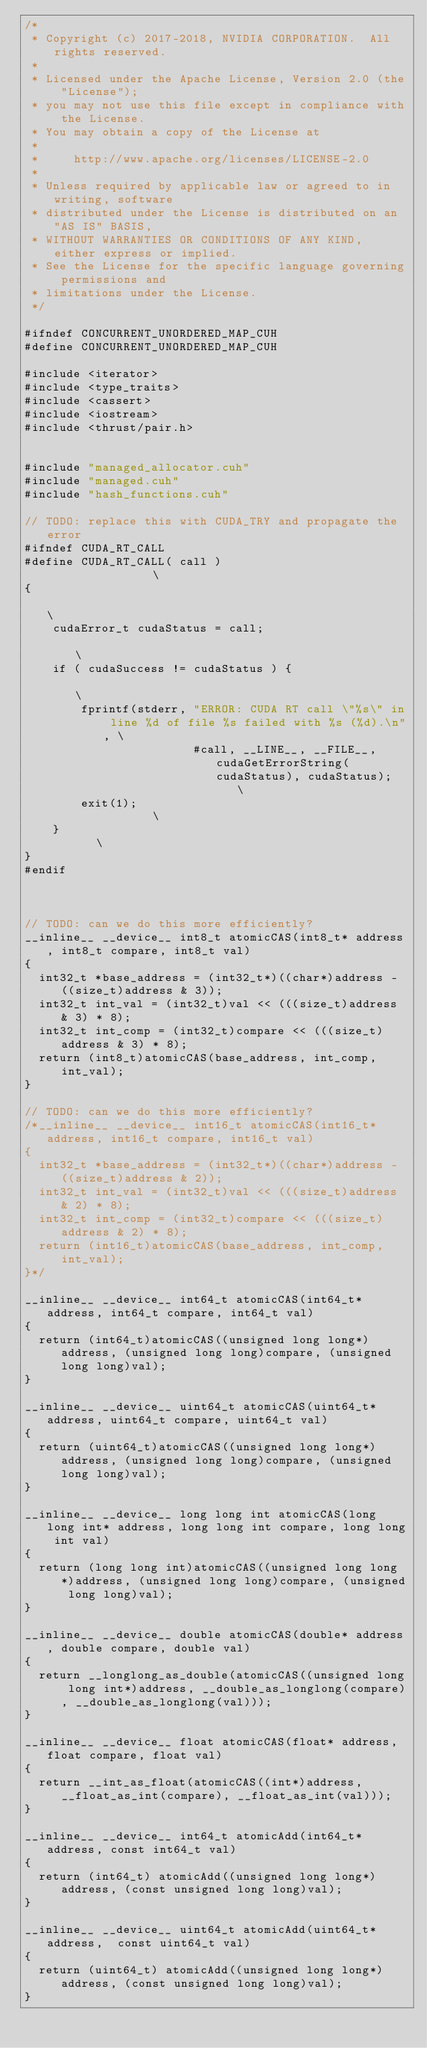Convert code to text. <code><loc_0><loc_0><loc_500><loc_500><_Cuda_>/*
 * Copyright (c) 2017-2018, NVIDIA CORPORATION.  All rights reserved.
 *
 * Licensed under the Apache License, Version 2.0 (the "License");
 * you may not use this file except in compliance with the License.
 * You may obtain a copy of the License at
 *
 *     http://www.apache.org/licenses/LICENSE-2.0
 *
 * Unless required by applicable law or agreed to in writing, software
 * distributed under the License is distributed on an "AS IS" BASIS,
 * WITHOUT WARRANTIES OR CONDITIONS OF ANY KIND, either express or implied.
 * See the License for the specific language governing permissions and
 * limitations under the License.
 */

#ifndef CONCURRENT_UNORDERED_MAP_CUH
#define CONCURRENT_UNORDERED_MAP_CUH

#include <iterator>
#include <type_traits>
#include <cassert>
#include <iostream>
#include <thrust/pair.h>


#include "managed_allocator.cuh"
#include "managed.cuh"
#include "hash_functions.cuh"

// TODO: replace this with CUDA_TRY and propagate the error
#ifndef CUDA_RT_CALL
#define CUDA_RT_CALL( call ) 									   \
{                                                                                                  \
    cudaError_t cudaStatus = call;                                                                 \
    if ( cudaSuccess != cudaStatus ) {                                                             \
        fprintf(stderr, "ERROR: CUDA RT call \"%s\" in line %d of file %s failed with %s (%d).\n", \
                        #call, __LINE__, __FILE__, cudaGetErrorString(cudaStatus), cudaStatus);    \
        exit(1);										   \
    }												   \
}
#endif



// TODO: can we do this more efficiently?
__inline__ __device__ int8_t atomicCAS(int8_t* address, int8_t compare, int8_t val)
{
  int32_t *base_address = (int32_t*)((char*)address - ((size_t)address & 3));
  int32_t int_val = (int32_t)val << (((size_t)address & 3) * 8);
  int32_t int_comp = (int32_t)compare << (((size_t)address & 3) * 8);
  return (int8_t)atomicCAS(base_address, int_comp, int_val);
}

// TODO: can we do this more efficiently?
/*__inline__ __device__ int16_t atomicCAS(int16_t* address, int16_t compare, int16_t val)
{
  int32_t *base_address = (int32_t*)((char*)address - ((size_t)address & 2));
  int32_t int_val = (int32_t)val << (((size_t)address & 2) * 8);
  int32_t int_comp = (int32_t)compare << (((size_t)address & 2) * 8);
  return (int16_t)atomicCAS(base_address, int_comp, int_val);
}*/

__inline__ __device__ int64_t atomicCAS(int64_t* address, int64_t compare, int64_t val)
{
  return (int64_t)atomicCAS((unsigned long long*)address, (unsigned long long)compare, (unsigned long long)val);
}

__inline__ __device__ uint64_t atomicCAS(uint64_t* address, uint64_t compare, uint64_t val)
{
  return (uint64_t)atomicCAS((unsigned long long*)address, (unsigned long long)compare, (unsigned long long)val);
}

__inline__ __device__ long long int atomicCAS(long long int* address, long long int compare, long long int val)
{
  return (long long int)atomicCAS((unsigned long long*)address, (unsigned long long)compare, (unsigned long long)val);
}

__inline__ __device__ double atomicCAS(double* address, double compare, double val)
{
  return __longlong_as_double(atomicCAS((unsigned long long int*)address, __double_as_longlong(compare), __double_as_longlong(val)));
}

__inline__ __device__ float atomicCAS(float* address, float compare, float val)
{
  return __int_as_float(atomicCAS((int*)address, __float_as_int(compare), __float_as_int(val)));
}

__inline__ __device__ int64_t atomicAdd(int64_t* address, const int64_t val)
{
  return (int64_t) atomicAdd((unsigned long long*)address, (const unsigned long long)val);
}

__inline__ __device__ uint64_t atomicAdd(uint64_t* address,  const uint64_t val)
{
  return (uint64_t) atomicAdd((unsigned long long*)address, (const unsigned long long)val);
}
</code> 